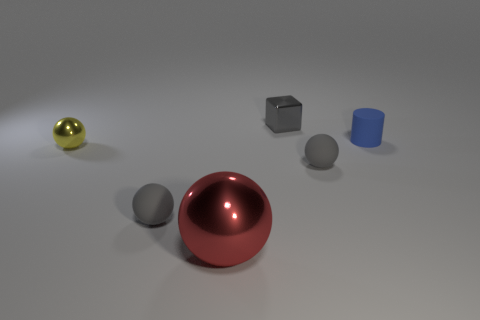Is there any other thing that has the same size as the red ball?
Provide a succinct answer. No. What is the thing that is both to the left of the small blue cylinder and behind the yellow metal thing made of?
Offer a terse response. Metal. How many yellow metal objects are the same shape as the gray metal object?
Provide a short and direct response. 0. There is a red ball that is in front of the gray metallic thing; what material is it?
Your response must be concise. Metal. Is the number of yellow balls that are on the right side of the gray block less than the number of small cylinders?
Provide a short and direct response. Yes. Is the shape of the yellow thing the same as the big metal thing?
Make the answer very short. Yes. Is there any other thing that is the same shape as the tiny blue matte thing?
Make the answer very short. No. Is there a big yellow shiny thing?
Your response must be concise. No. Does the yellow thing have the same shape as the large red thing that is on the left side of the matte cylinder?
Make the answer very short. Yes. What material is the gray thing that is behind the yellow object to the left of the large metallic thing?
Give a very brief answer. Metal. 